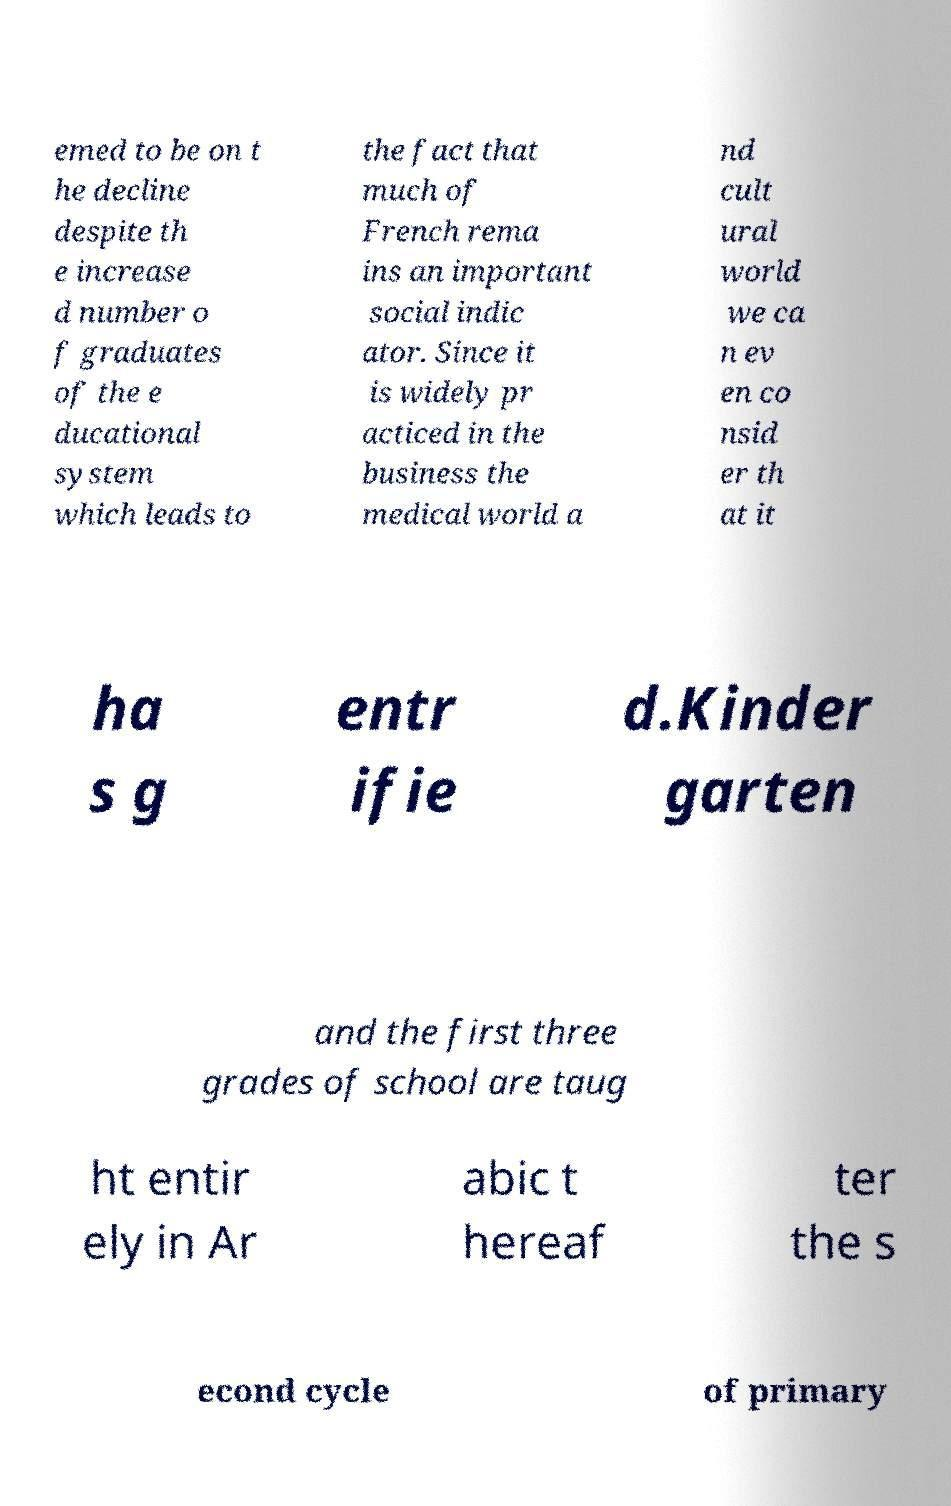Please identify and transcribe the text found in this image. emed to be on t he decline despite th e increase d number o f graduates of the e ducational system which leads to the fact that much of French rema ins an important social indic ator. Since it is widely pr acticed in the business the medical world a nd cult ural world we ca n ev en co nsid er th at it ha s g entr ifie d.Kinder garten and the first three grades of school are taug ht entir ely in Ar abic t hereaf ter the s econd cycle of primary 